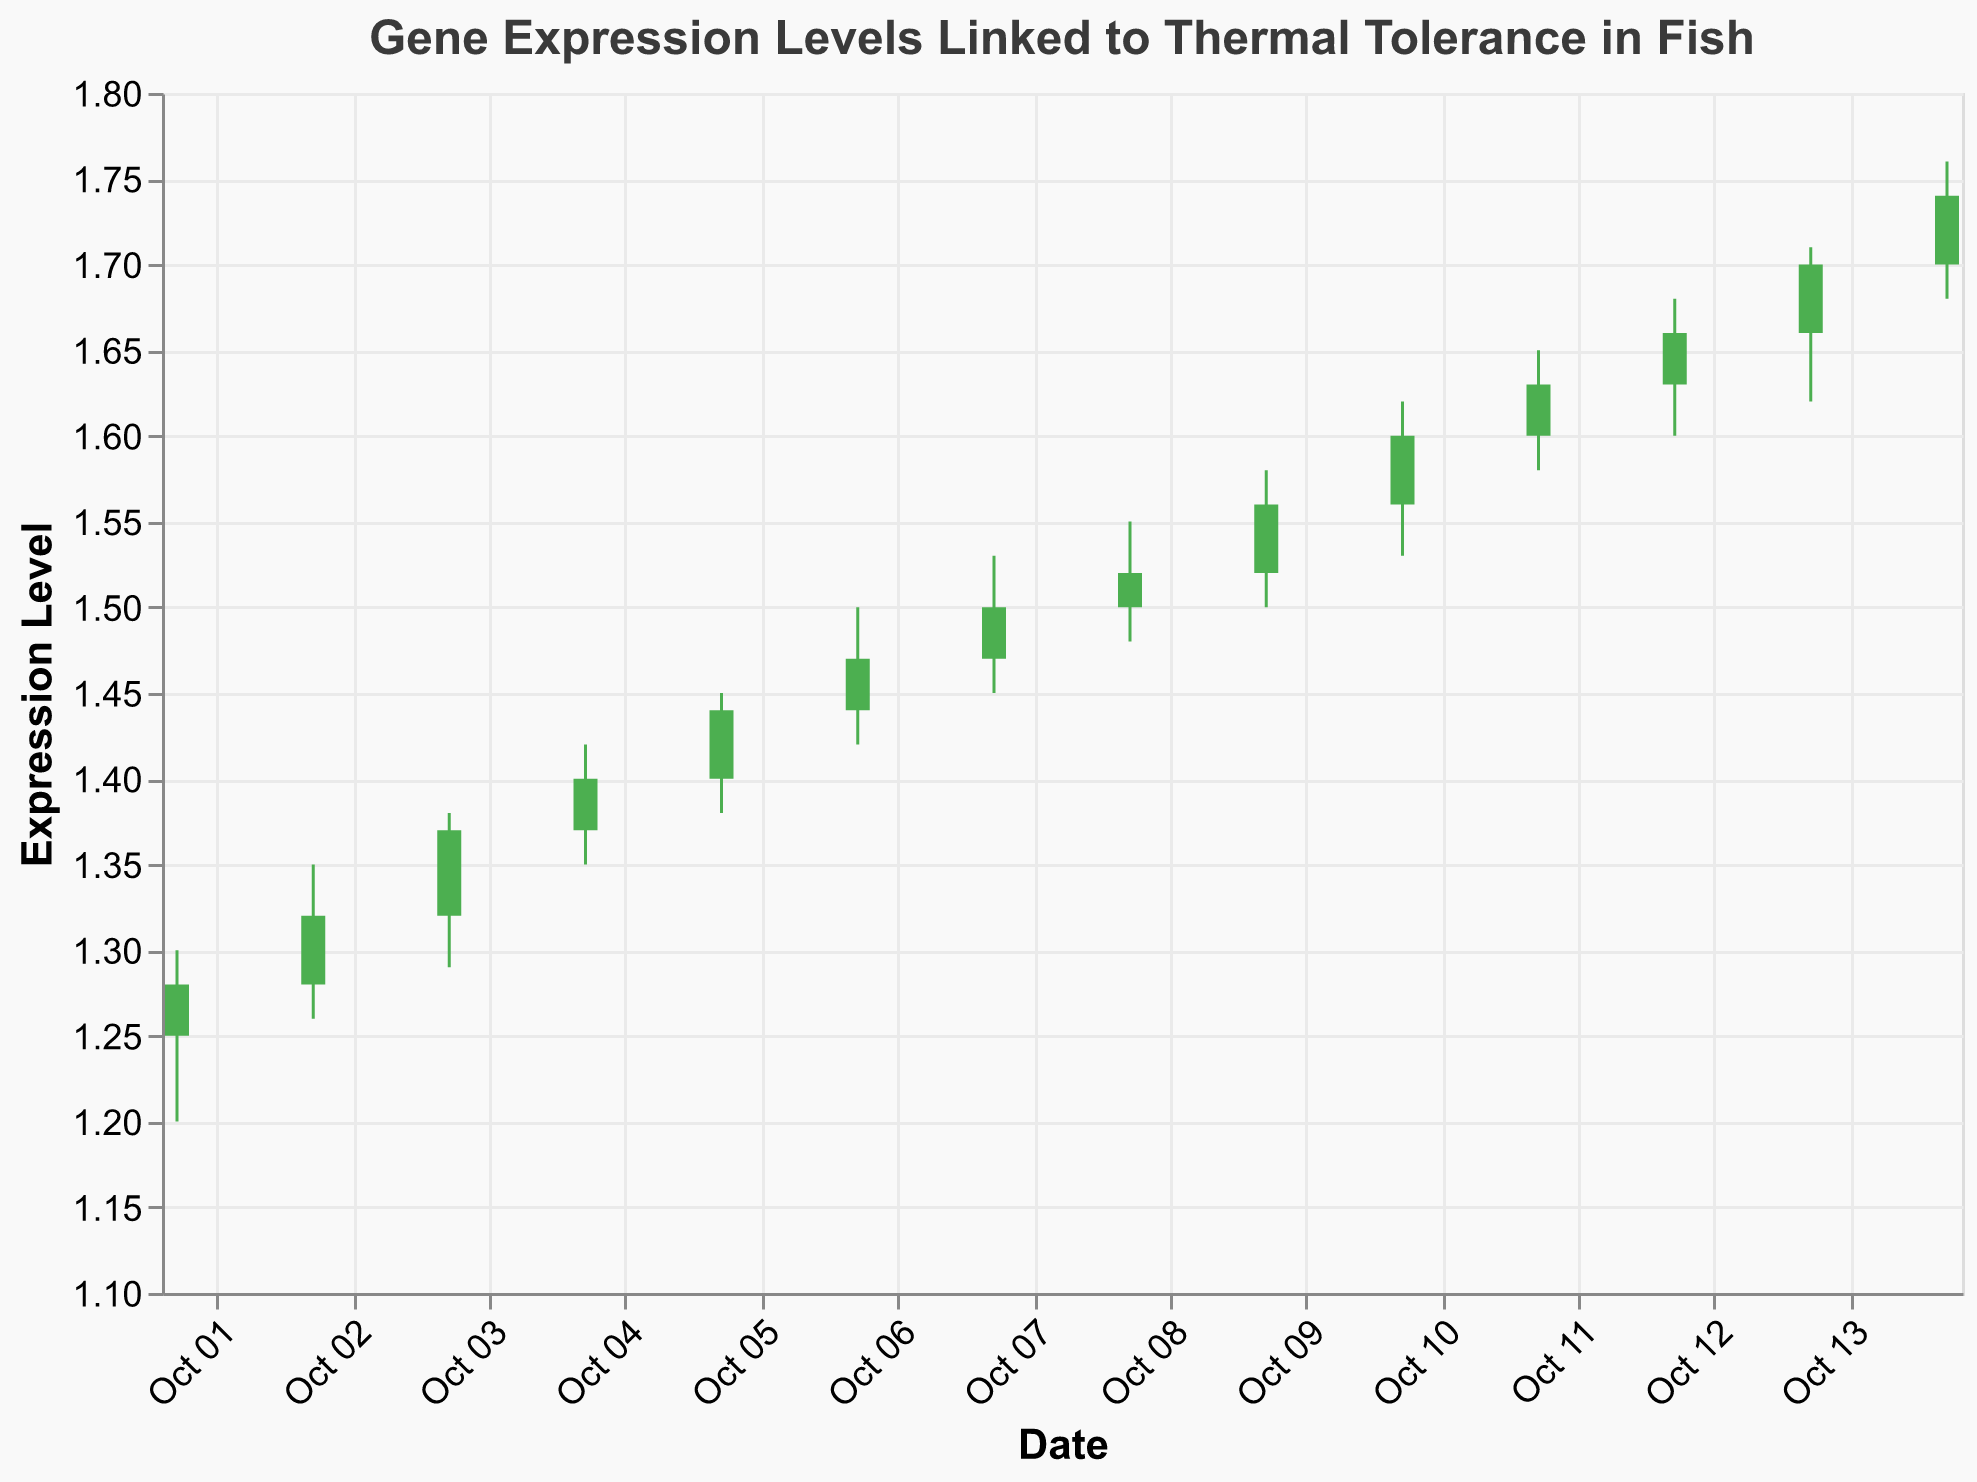What is the title of the figure? The title is usually displayed at the top of the chart. In this case, it reads "Gene Expression Levels Linked to Thermal Tolerance in Fish".
Answer: Gene Expression Levels Linked to Thermal Tolerance in Fish What does the y-axis represent? The y-axis label reads "Expression Level", indicating it represents the levels of gene expression.
Answer: Expression Level Which date has the highest "High" value and what is that value? By inspecting the peaks of the candlesticks (the top of the lines extending from the bars), the highest peak occurs on 2023-10-14 with a value of 1.76.
Answer: 2023-10-14, 1.76 On which dates did the expression level close higher than it opened? A bar color change (green) signifies the close value is greater than the open value. These dates are from 2023-10-01 to 2023-10-14, indicating an upward trend each day.
Answer: All dates from 2023-10-01 to 2023-10-14 What is the average closing expression level over the 14 days? Sum all the closing values and divide by the number of days. (1.28 + 1.32 + 1.37 + 1.40 + 1.44 + 1.47 + 1.50 + 1.52 + 1.56 + 1.60 + 1.63 + 1.66 + 1.70 + 1.74) / 14 = 1.501
Answer: 1.501 On which date did the lowest "Low" value occur? Observe the bottom ends of the lines from the candlesticks. The lowest point occurs at 1.20 on 2023-10-01.
Answer: 2023-10-01 Which day had the highest trading volume? The volume, indicated in the dataset but not visualized, is highest on 2023-10-07 with 19000.
Answer: 2023-10-07 Which day shows the smallest range between the "High" and "Low" values? Calculate the range for each day and find the smallest: Range = High - Low. For 2023-10-02, the range is 1.35 - 1.26 = 0.09, which is the smallest.
Answer: 2023-10-02 What are the opening and closing values on 2023-10-10? Refer to the horizontal spans of the candlesticks for 2023-10-10: Open = 1.56 and Close = 1.60.
Answer: Open: 1.56, Close: 1.60 Does the trend in expression levels appear to be increasing, decreasing, or remaining stable over the period? The overall trend looks like an increasing one, as each day's closing value is generally higher than the previous day's closing value.
Answer: Increasing 